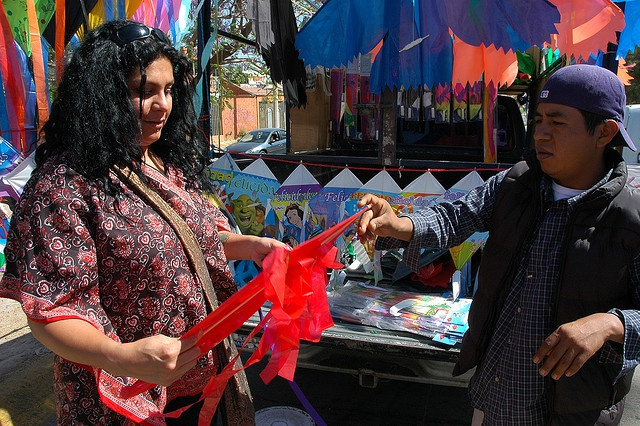Describe the objects in this image and their specific colors. I can see people in red, black, maroon, gray, and brown tones, people in red, black, maroon, and gray tones, kite in red, navy, darkblue, blue, and purple tones, kite in red, brown, and salmon tones, and kite in red, salmon, and brown tones in this image. 